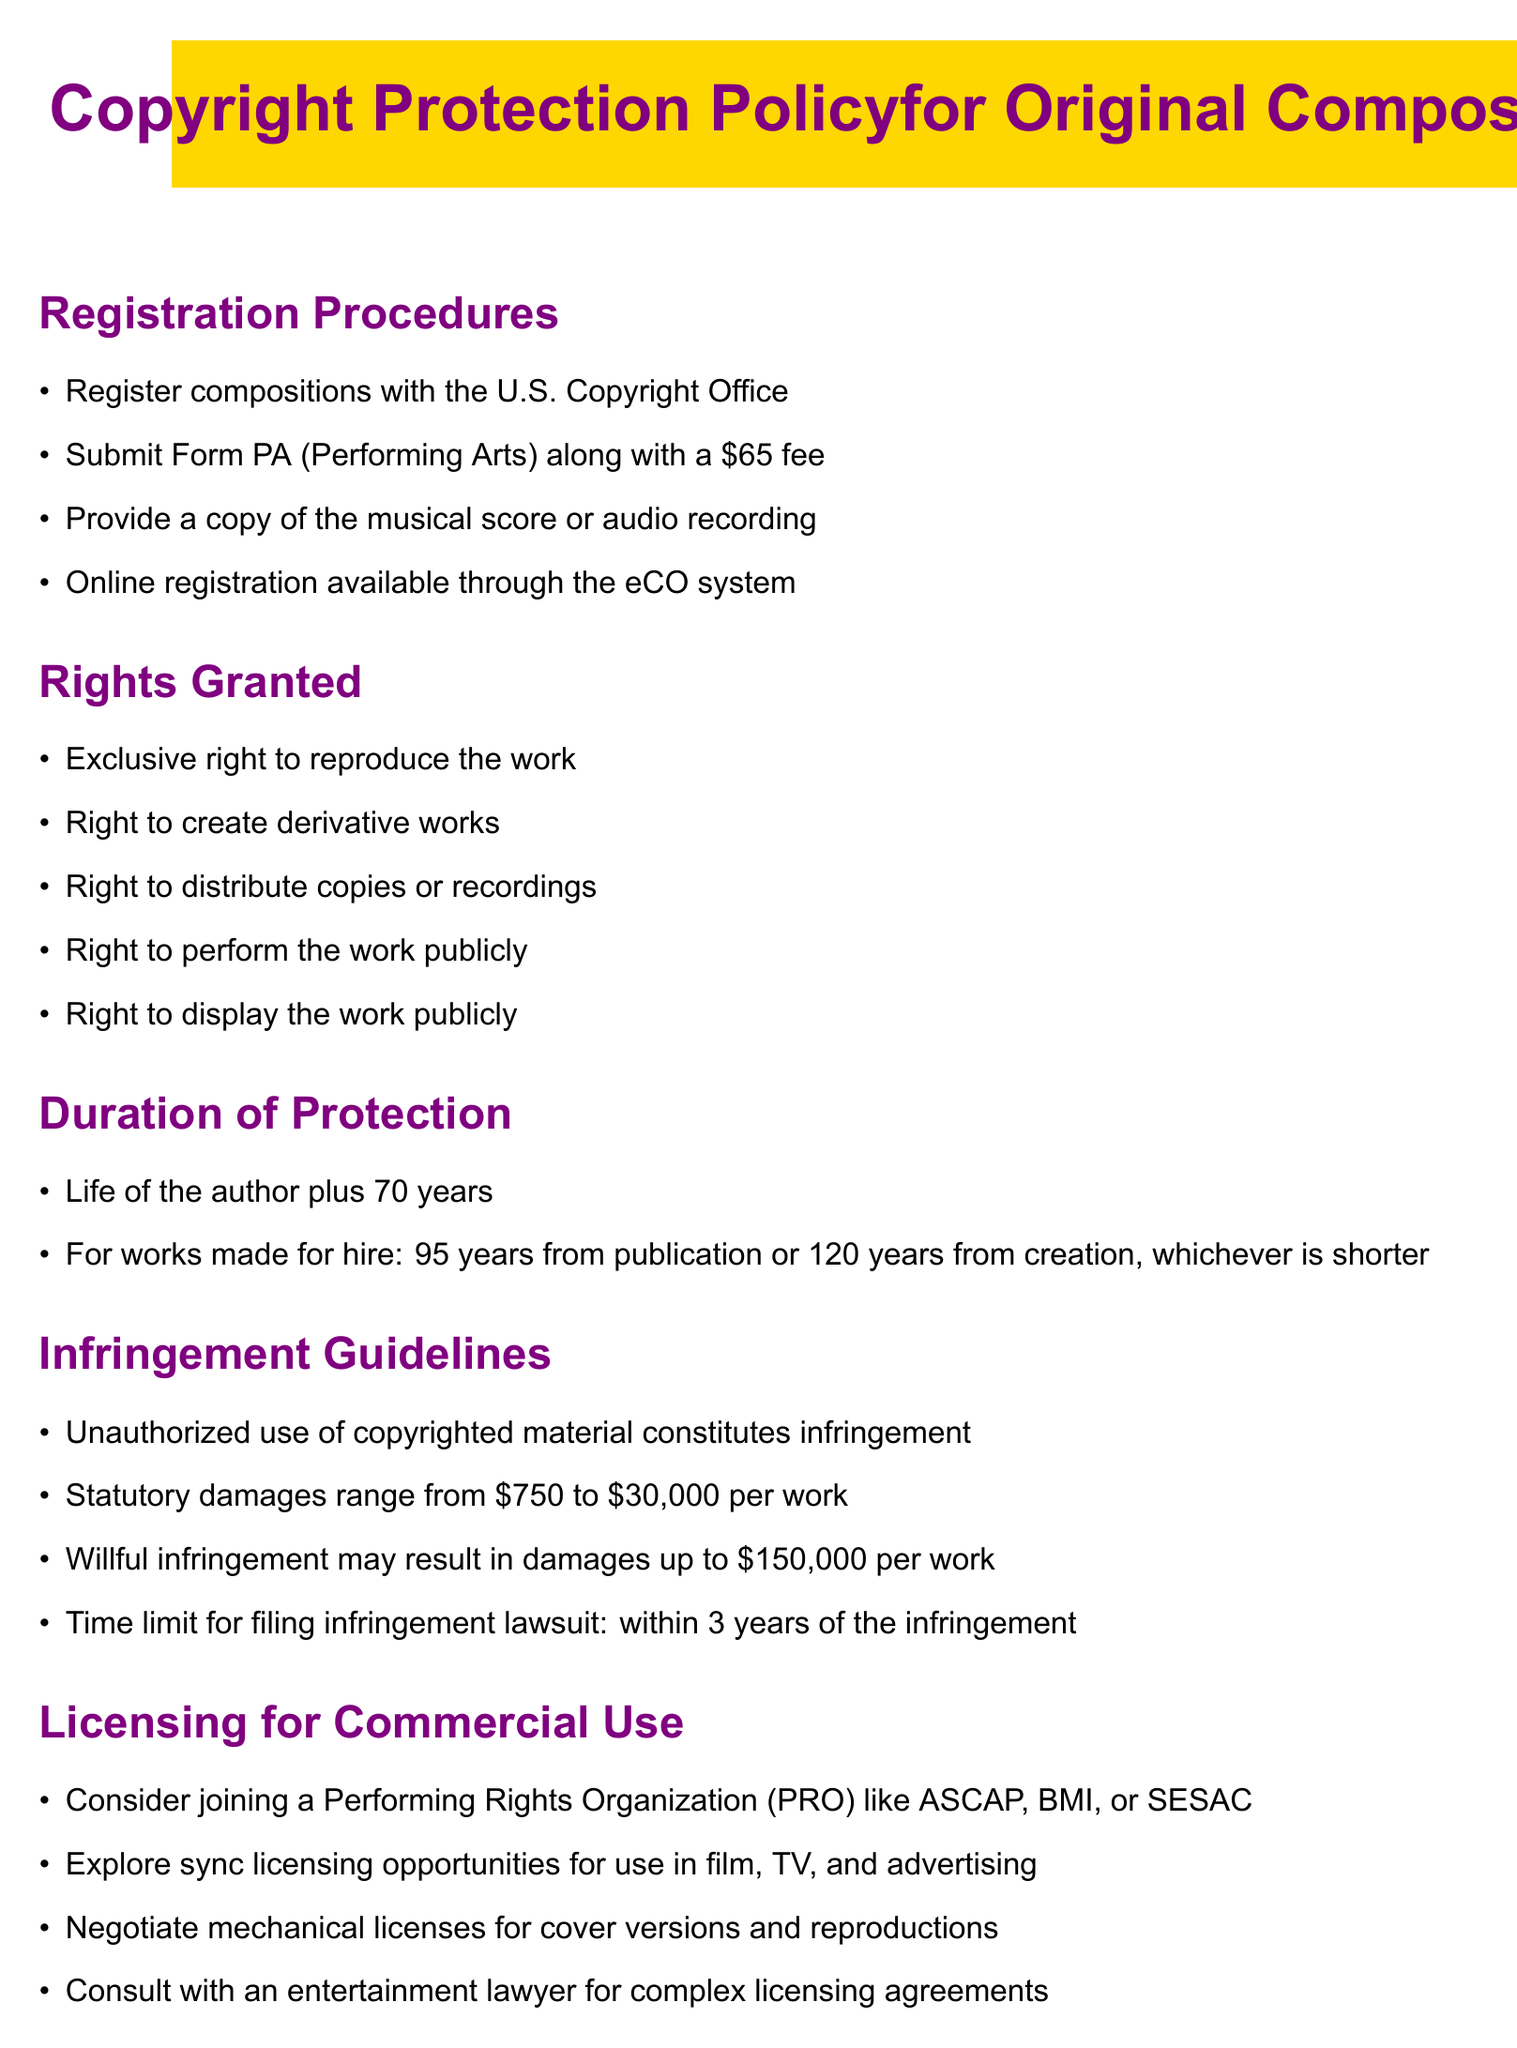What is the registration fee for Form PA? The registration fee for Form PA is mentioned in the document and is stated clearly.
Answer: $65 What rights are granted upon copyright registration? The rights granted are listed in the section about rights granted, covering various aspects.
Answer: Exclusive right to reproduce the work What is the duration of protection for an author's work? The duration of protection is explicitly defined in the document for individual authors.
Answer: Life of the author plus 70 years What are the statutory damages for infringement? The document specifies the range of statutory damages associated with infringement.
Answer: $750 to $30,000 per work How long do you have to file an infringement lawsuit? The time limit for filing an infringement lawsuit is given in the infringement guidelines section.
Answer: Within 3 years Which organizations should you consider joining for licensing? The document mentions specific Performing Rights Organizations that are advisable to join.
Answer: ASCAP, BMI, or SESAC What is the purpose of a mechanical license according to the document? The document describes the mechanical license in the context of reproduction rights.
Answer: For cover versions and reproductions What type of lawyer should you consult for complex licensing agreements? The document advises on the type of legal advice recommended for licensing arrangements.
Answer: Entertainment lawyer 